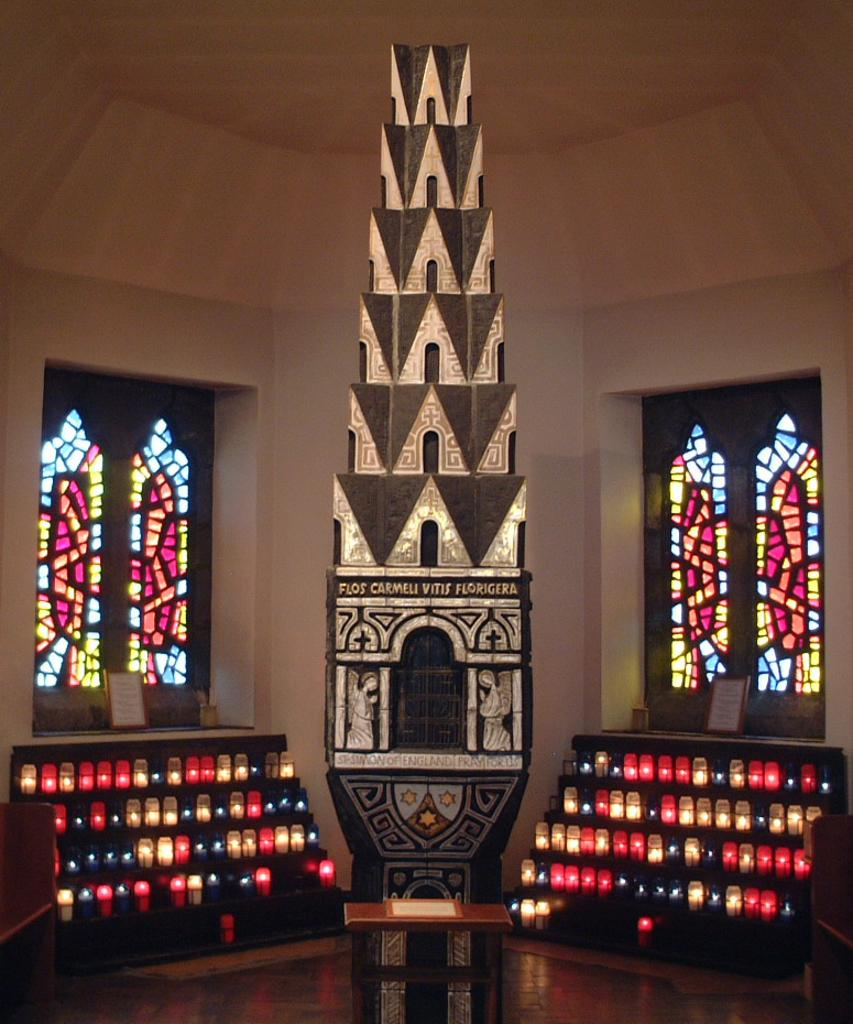What can be seen in the image that provides illumination? There are lights in the image. What type of furniture is present in the image? There is a table in the image. What type of structure is depicted in the image? The image contains architecture. What type of windows are present in the image? Stained glass windows are present in the image. What is visible in the background of the image? There is a wall visible in the background of the image. How does the cork contribute to the comfort of the room in the image? There is no cork present in the image, so it cannot contribute to the comfort of the room. 